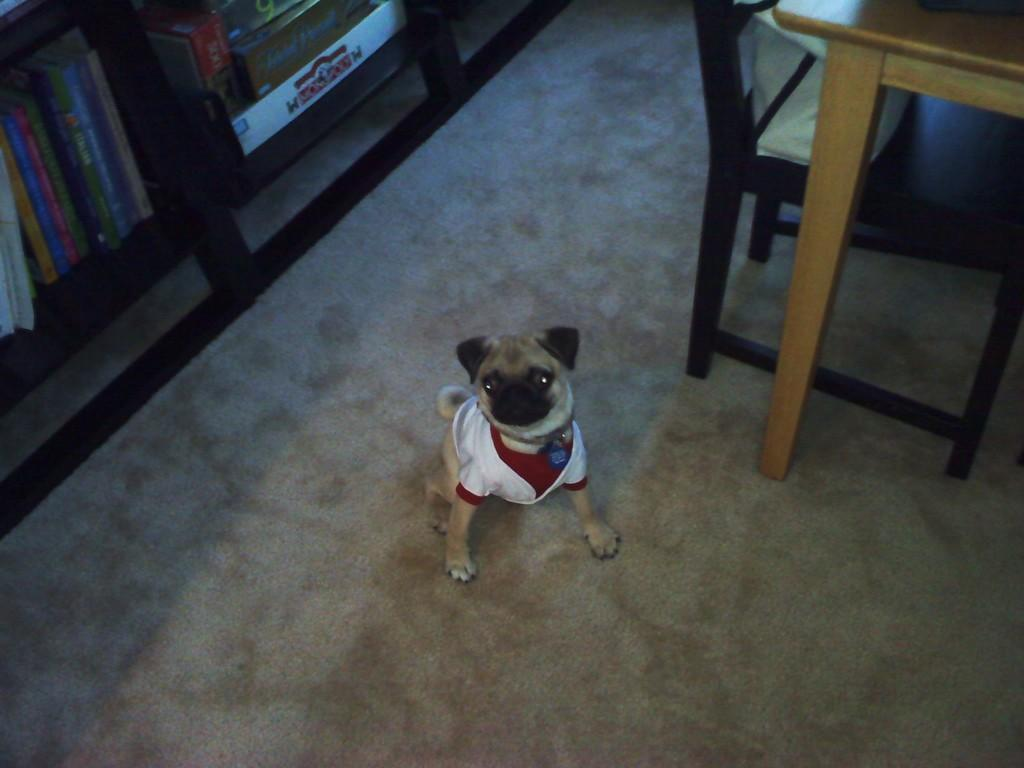What type of animal is present in the image? There is a dog in the image. What can be seen in the background of the image? There are books in the background of the image. What type of stem can be seen growing from the dog's head in the image? There is no stem growing from the dog's head in the image. Is the dog in the image driving a car? No, the dog in the image is not driving a car. 